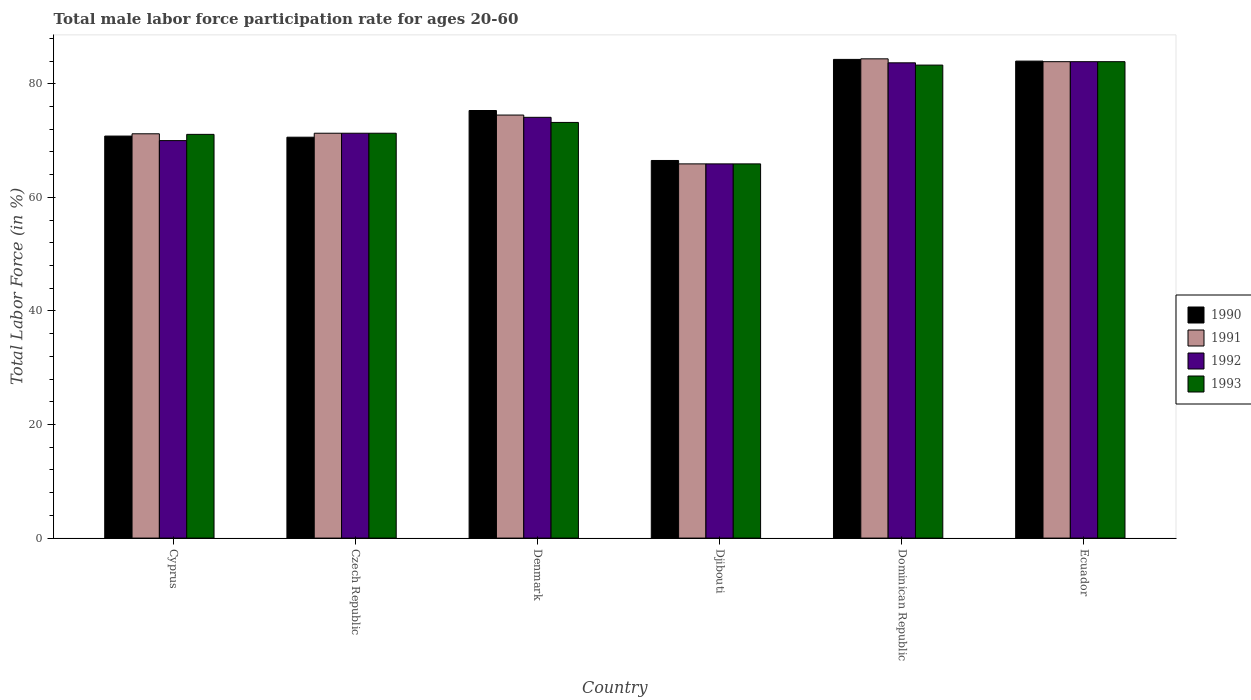Are the number of bars per tick equal to the number of legend labels?
Keep it short and to the point. Yes. What is the label of the 1st group of bars from the left?
Your response must be concise. Cyprus. What is the male labor force participation rate in 1990 in Djibouti?
Keep it short and to the point. 66.5. Across all countries, what is the maximum male labor force participation rate in 1992?
Provide a short and direct response. 83.9. Across all countries, what is the minimum male labor force participation rate in 1992?
Your answer should be very brief. 65.9. In which country was the male labor force participation rate in 1990 maximum?
Your answer should be very brief. Dominican Republic. In which country was the male labor force participation rate in 1991 minimum?
Provide a succinct answer. Djibouti. What is the total male labor force participation rate in 1992 in the graph?
Give a very brief answer. 448.9. What is the difference between the male labor force participation rate in 1993 in Djibouti and that in Ecuador?
Make the answer very short. -18. What is the difference between the male labor force participation rate in 1990 in Denmark and the male labor force participation rate in 1993 in Ecuador?
Your response must be concise. -8.6. What is the average male labor force participation rate in 1992 per country?
Your answer should be compact. 74.82. What is the difference between the male labor force participation rate of/in 1992 and male labor force participation rate of/in 1990 in Czech Republic?
Make the answer very short. 0.7. What is the ratio of the male labor force participation rate in 1993 in Czech Republic to that in Djibouti?
Ensure brevity in your answer.  1.08. Is the male labor force participation rate in 1991 in Dominican Republic less than that in Ecuador?
Provide a succinct answer. No. What is the difference between the highest and the second highest male labor force participation rate in 1990?
Provide a succinct answer. -9. What is the difference between the highest and the lowest male labor force participation rate in 1992?
Ensure brevity in your answer.  18. In how many countries, is the male labor force participation rate in 1990 greater than the average male labor force participation rate in 1990 taken over all countries?
Make the answer very short. 3. Is the sum of the male labor force participation rate in 1990 in Cyprus and Czech Republic greater than the maximum male labor force participation rate in 1993 across all countries?
Provide a short and direct response. Yes. What does the 2nd bar from the left in Cyprus represents?
Your answer should be very brief. 1991. What does the 3rd bar from the right in Denmark represents?
Your answer should be compact. 1991. Is it the case that in every country, the sum of the male labor force participation rate in 1990 and male labor force participation rate in 1991 is greater than the male labor force participation rate in 1993?
Make the answer very short. Yes. How many countries are there in the graph?
Provide a succinct answer. 6. Are the values on the major ticks of Y-axis written in scientific E-notation?
Provide a short and direct response. No. Does the graph contain any zero values?
Provide a succinct answer. No. Where does the legend appear in the graph?
Give a very brief answer. Center right. What is the title of the graph?
Your answer should be very brief. Total male labor force participation rate for ages 20-60. What is the label or title of the Y-axis?
Make the answer very short. Total Labor Force (in %). What is the Total Labor Force (in %) of 1990 in Cyprus?
Offer a terse response. 70.8. What is the Total Labor Force (in %) of 1991 in Cyprus?
Keep it short and to the point. 71.2. What is the Total Labor Force (in %) of 1992 in Cyprus?
Offer a terse response. 70. What is the Total Labor Force (in %) of 1993 in Cyprus?
Provide a succinct answer. 71.1. What is the Total Labor Force (in %) in 1990 in Czech Republic?
Keep it short and to the point. 70.6. What is the Total Labor Force (in %) of 1991 in Czech Republic?
Make the answer very short. 71.3. What is the Total Labor Force (in %) of 1992 in Czech Republic?
Offer a terse response. 71.3. What is the Total Labor Force (in %) in 1993 in Czech Republic?
Provide a short and direct response. 71.3. What is the Total Labor Force (in %) in 1990 in Denmark?
Offer a very short reply. 75.3. What is the Total Labor Force (in %) in 1991 in Denmark?
Offer a very short reply. 74.5. What is the Total Labor Force (in %) in 1992 in Denmark?
Give a very brief answer. 74.1. What is the Total Labor Force (in %) in 1993 in Denmark?
Your answer should be compact. 73.2. What is the Total Labor Force (in %) in 1990 in Djibouti?
Offer a very short reply. 66.5. What is the Total Labor Force (in %) in 1991 in Djibouti?
Your response must be concise. 65.9. What is the Total Labor Force (in %) of 1992 in Djibouti?
Your answer should be very brief. 65.9. What is the Total Labor Force (in %) of 1993 in Djibouti?
Keep it short and to the point. 65.9. What is the Total Labor Force (in %) of 1990 in Dominican Republic?
Provide a short and direct response. 84.3. What is the Total Labor Force (in %) in 1991 in Dominican Republic?
Offer a terse response. 84.4. What is the Total Labor Force (in %) in 1992 in Dominican Republic?
Give a very brief answer. 83.7. What is the Total Labor Force (in %) of 1993 in Dominican Republic?
Offer a very short reply. 83.3. What is the Total Labor Force (in %) of 1991 in Ecuador?
Provide a succinct answer. 83.9. What is the Total Labor Force (in %) of 1992 in Ecuador?
Your response must be concise. 83.9. What is the Total Labor Force (in %) in 1993 in Ecuador?
Your answer should be compact. 83.9. Across all countries, what is the maximum Total Labor Force (in %) of 1990?
Your answer should be very brief. 84.3. Across all countries, what is the maximum Total Labor Force (in %) of 1991?
Your response must be concise. 84.4. Across all countries, what is the maximum Total Labor Force (in %) in 1992?
Keep it short and to the point. 83.9. Across all countries, what is the maximum Total Labor Force (in %) in 1993?
Your response must be concise. 83.9. Across all countries, what is the minimum Total Labor Force (in %) in 1990?
Your response must be concise. 66.5. Across all countries, what is the minimum Total Labor Force (in %) in 1991?
Provide a short and direct response. 65.9. Across all countries, what is the minimum Total Labor Force (in %) in 1992?
Give a very brief answer. 65.9. Across all countries, what is the minimum Total Labor Force (in %) of 1993?
Offer a terse response. 65.9. What is the total Total Labor Force (in %) in 1990 in the graph?
Provide a succinct answer. 451.5. What is the total Total Labor Force (in %) of 1991 in the graph?
Your answer should be compact. 451.2. What is the total Total Labor Force (in %) of 1992 in the graph?
Keep it short and to the point. 448.9. What is the total Total Labor Force (in %) of 1993 in the graph?
Your answer should be compact. 448.7. What is the difference between the Total Labor Force (in %) in 1991 in Cyprus and that in Czech Republic?
Offer a terse response. -0.1. What is the difference between the Total Labor Force (in %) of 1992 in Cyprus and that in Czech Republic?
Keep it short and to the point. -1.3. What is the difference between the Total Labor Force (in %) in 1990 in Cyprus and that in Denmark?
Provide a short and direct response. -4.5. What is the difference between the Total Labor Force (in %) in 1993 in Cyprus and that in Denmark?
Provide a short and direct response. -2.1. What is the difference between the Total Labor Force (in %) in 1990 in Cyprus and that in Djibouti?
Offer a very short reply. 4.3. What is the difference between the Total Labor Force (in %) of 1992 in Cyprus and that in Djibouti?
Offer a very short reply. 4.1. What is the difference between the Total Labor Force (in %) of 1990 in Cyprus and that in Dominican Republic?
Keep it short and to the point. -13.5. What is the difference between the Total Labor Force (in %) in 1991 in Cyprus and that in Dominican Republic?
Make the answer very short. -13.2. What is the difference between the Total Labor Force (in %) in 1992 in Cyprus and that in Dominican Republic?
Your answer should be very brief. -13.7. What is the difference between the Total Labor Force (in %) of 1991 in Cyprus and that in Ecuador?
Keep it short and to the point. -12.7. What is the difference between the Total Labor Force (in %) in 1992 in Czech Republic and that in Denmark?
Your response must be concise. -2.8. What is the difference between the Total Labor Force (in %) in 1990 in Czech Republic and that in Djibouti?
Keep it short and to the point. 4.1. What is the difference between the Total Labor Force (in %) of 1991 in Czech Republic and that in Djibouti?
Offer a very short reply. 5.4. What is the difference between the Total Labor Force (in %) of 1993 in Czech Republic and that in Djibouti?
Your answer should be very brief. 5.4. What is the difference between the Total Labor Force (in %) in 1990 in Czech Republic and that in Dominican Republic?
Your response must be concise. -13.7. What is the difference between the Total Labor Force (in %) in 1991 in Czech Republic and that in Dominican Republic?
Your response must be concise. -13.1. What is the difference between the Total Labor Force (in %) in 1993 in Czech Republic and that in Dominican Republic?
Offer a terse response. -12. What is the difference between the Total Labor Force (in %) of 1990 in Czech Republic and that in Ecuador?
Offer a terse response. -13.4. What is the difference between the Total Labor Force (in %) in 1993 in Czech Republic and that in Ecuador?
Provide a succinct answer. -12.6. What is the difference between the Total Labor Force (in %) in 1990 in Denmark and that in Djibouti?
Your response must be concise. 8.8. What is the difference between the Total Labor Force (in %) of 1991 in Denmark and that in Djibouti?
Give a very brief answer. 8.6. What is the difference between the Total Labor Force (in %) in 1992 in Denmark and that in Djibouti?
Provide a succinct answer. 8.2. What is the difference between the Total Labor Force (in %) of 1991 in Denmark and that in Dominican Republic?
Offer a terse response. -9.9. What is the difference between the Total Labor Force (in %) in 1992 in Denmark and that in Dominican Republic?
Ensure brevity in your answer.  -9.6. What is the difference between the Total Labor Force (in %) of 1990 in Djibouti and that in Dominican Republic?
Give a very brief answer. -17.8. What is the difference between the Total Labor Force (in %) in 1991 in Djibouti and that in Dominican Republic?
Keep it short and to the point. -18.5. What is the difference between the Total Labor Force (in %) in 1992 in Djibouti and that in Dominican Republic?
Offer a terse response. -17.8. What is the difference between the Total Labor Force (in %) in 1993 in Djibouti and that in Dominican Republic?
Your response must be concise. -17.4. What is the difference between the Total Labor Force (in %) of 1990 in Djibouti and that in Ecuador?
Your response must be concise. -17.5. What is the difference between the Total Labor Force (in %) in 1993 in Djibouti and that in Ecuador?
Your answer should be very brief. -18. What is the difference between the Total Labor Force (in %) of 1990 in Dominican Republic and that in Ecuador?
Your response must be concise. 0.3. What is the difference between the Total Labor Force (in %) in 1992 in Dominican Republic and that in Ecuador?
Your response must be concise. -0.2. What is the difference between the Total Labor Force (in %) in 1990 in Cyprus and the Total Labor Force (in %) in 1991 in Czech Republic?
Give a very brief answer. -0.5. What is the difference between the Total Labor Force (in %) of 1992 in Cyprus and the Total Labor Force (in %) of 1993 in Czech Republic?
Ensure brevity in your answer.  -1.3. What is the difference between the Total Labor Force (in %) in 1990 in Cyprus and the Total Labor Force (in %) in 1992 in Denmark?
Offer a very short reply. -3.3. What is the difference between the Total Labor Force (in %) of 1991 in Cyprus and the Total Labor Force (in %) of 1992 in Denmark?
Give a very brief answer. -2.9. What is the difference between the Total Labor Force (in %) of 1991 in Cyprus and the Total Labor Force (in %) of 1993 in Denmark?
Your answer should be compact. -2. What is the difference between the Total Labor Force (in %) of 1990 in Cyprus and the Total Labor Force (in %) of 1991 in Djibouti?
Your response must be concise. 4.9. What is the difference between the Total Labor Force (in %) of 1990 in Cyprus and the Total Labor Force (in %) of 1992 in Djibouti?
Give a very brief answer. 4.9. What is the difference between the Total Labor Force (in %) of 1991 in Cyprus and the Total Labor Force (in %) of 1993 in Djibouti?
Your response must be concise. 5.3. What is the difference between the Total Labor Force (in %) in 1990 in Cyprus and the Total Labor Force (in %) in 1991 in Dominican Republic?
Your answer should be very brief. -13.6. What is the difference between the Total Labor Force (in %) in 1990 in Cyprus and the Total Labor Force (in %) in 1992 in Dominican Republic?
Provide a succinct answer. -12.9. What is the difference between the Total Labor Force (in %) of 1991 in Cyprus and the Total Labor Force (in %) of 1993 in Dominican Republic?
Provide a succinct answer. -12.1. What is the difference between the Total Labor Force (in %) in 1992 in Cyprus and the Total Labor Force (in %) in 1993 in Dominican Republic?
Provide a succinct answer. -13.3. What is the difference between the Total Labor Force (in %) of 1990 in Cyprus and the Total Labor Force (in %) of 1991 in Ecuador?
Keep it short and to the point. -13.1. What is the difference between the Total Labor Force (in %) in 1990 in Cyprus and the Total Labor Force (in %) in 1993 in Ecuador?
Your response must be concise. -13.1. What is the difference between the Total Labor Force (in %) in 1991 in Cyprus and the Total Labor Force (in %) in 1992 in Ecuador?
Provide a succinct answer. -12.7. What is the difference between the Total Labor Force (in %) of 1992 in Cyprus and the Total Labor Force (in %) of 1993 in Ecuador?
Make the answer very short. -13.9. What is the difference between the Total Labor Force (in %) of 1990 in Czech Republic and the Total Labor Force (in %) of 1991 in Denmark?
Keep it short and to the point. -3.9. What is the difference between the Total Labor Force (in %) of 1990 in Czech Republic and the Total Labor Force (in %) of 1992 in Denmark?
Keep it short and to the point. -3.5. What is the difference between the Total Labor Force (in %) of 1992 in Czech Republic and the Total Labor Force (in %) of 1993 in Denmark?
Provide a succinct answer. -1.9. What is the difference between the Total Labor Force (in %) of 1990 in Czech Republic and the Total Labor Force (in %) of 1991 in Djibouti?
Offer a very short reply. 4.7. What is the difference between the Total Labor Force (in %) of 1990 in Czech Republic and the Total Labor Force (in %) of 1993 in Djibouti?
Offer a very short reply. 4.7. What is the difference between the Total Labor Force (in %) of 1991 in Czech Republic and the Total Labor Force (in %) of 1992 in Djibouti?
Ensure brevity in your answer.  5.4. What is the difference between the Total Labor Force (in %) of 1991 in Czech Republic and the Total Labor Force (in %) of 1993 in Djibouti?
Provide a succinct answer. 5.4. What is the difference between the Total Labor Force (in %) in 1992 in Czech Republic and the Total Labor Force (in %) in 1993 in Djibouti?
Make the answer very short. 5.4. What is the difference between the Total Labor Force (in %) of 1990 in Czech Republic and the Total Labor Force (in %) of 1991 in Dominican Republic?
Make the answer very short. -13.8. What is the difference between the Total Labor Force (in %) of 1990 in Czech Republic and the Total Labor Force (in %) of 1992 in Dominican Republic?
Your answer should be compact. -13.1. What is the difference between the Total Labor Force (in %) of 1991 in Czech Republic and the Total Labor Force (in %) of 1992 in Dominican Republic?
Your answer should be compact. -12.4. What is the difference between the Total Labor Force (in %) in 1991 in Czech Republic and the Total Labor Force (in %) in 1993 in Dominican Republic?
Give a very brief answer. -12. What is the difference between the Total Labor Force (in %) of 1990 in Czech Republic and the Total Labor Force (in %) of 1991 in Ecuador?
Offer a very short reply. -13.3. What is the difference between the Total Labor Force (in %) of 1990 in Czech Republic and the Total Labor Force (in %) of 1992 in Ecuador?
Your answer should be very brief. -13.3. What is the difference between the Total Labor Force (in %) of 1990 in Czech Republic and the Total Labor Force (in %) of 1993 in Ecuador?
Give a very brief answer. -13.3. What is the difference between the Total Labor Force (in %) in 1990 in Denmark and the Total Labor Force (in %) in 1991 in Djibouti?
Your response must be concise. 9.4. What is the difference between the Total Labor Force (in %) in 1990 in Denmark and the Total Labor Force (in %) in 1993 in Djibouti?
Ensure brevity in your answer.  9.4. What is the difference between the Total Labor Force (in %) of 1991 in Denmark and the Total Labor Force (in %) of 1992 in Djibouti?
Provide a short and direct response. 8.6. What is the difference between the Total Labor Force (in %) in 1992 in Denmark and the Total Labor Force (in %) in 1993 in Djibouti?
Keep it short and to the point. 8.2. What is the difference between the Total Labor Force (in %) of 1990 in Denmark and the Total Labor Force (in %) of 1991 in Dominican Republic?
Offer a very short reply. -9.1. What is the difference between the Total Labor Force (in %) in 1990 in Denmark and the Total Labor Force (in %) in 1992 in Dominican Republic?
Provide a succinct answer. -8.4. What is the difference between the Total Labor Force (in %) in 1990 in Denmark and the Total Labor Force (in %) in 1993 in Dominican Republic?
Offer a terse response. -8. What is the difference between the Total Labor Force (in %) of 1991 in Denmark and the Total Labor Force (in %) of 1993 in Dominican Republic?
Your answer should be very brief. -8.8. What is the difference between the Total Labor Force (in %) in 1992 in Denmark and the Total Labor Force (in %) in 1993 in Dominican Republic?
Provide a succinct answer. -9.2. What is the difference between the Total Labor Force (in %) in 1990 in Denmark and the Total Labor Force (in %) in 1991 in Ecuador?
Your answer should be very brief. -8.6. What is the difference between the Total Labor Force (in %) in 1990 in Denmark and the Total Labor Force (in %) in 1992 in Ecuador?
Give a very brief answer. -8.6. What is the difference between the Total Labor Force (in %) in 1991 in Denmark and the Total Labor Force (in %) in 1993 in Ecuador?
Make the answer very short. -9.4. What is the difference between the Total Labor Force (in %) in 1990 in Djibouti and the Total Labor Force (in %) in 1991 in Dominican Republic?
Provide a succinct answer. -17.9. What is the difference between the Total Labor Force (in %) of 1990 in Djibouti and the Total Labor Force (in %) of 1992 in Dominican Republic?
Your response must be concise. -17.2. What is the difference between the Total Labor Force (in %) in 1990 in Djibouti and the Total Labor Force (in %) in 1993 in Dominican Republic?
Provide a short and direct response. -16.8. What is the difference between the Total Labor Force (in %) of 1991 in Djibouti and the Total Labor Force (in %) of 1992 in Dominican Republic?
Give a very brief answer. -17.8. What is the difference between the Total Labor Force (in %) of 1991 in Djibouti and the Total Labor Force (in %) of 1993 in Dominican Republic?
Offer a terse response. -17.4. What is the difference between the Total Labor Force (in %) of 1992 in Djibouti and the Total Labor Force (in %) of 1993 in Dominican Republic?
Ensure brevity in your answer.  -17.4. What is the difference between the Total Labor Force (in %) in 1990 in Djibouti and the Total Labor Force (in %) in 1991 in Ecuador?
Provide a short and direct response. -17.4. What is the difference between the Total Labor Force (in %) in 1990 in Djibouti and the Total Labor Force (in %) in 1992 in Ecuador?
Keep it short and to the point. -17.4. What is the difference between the Total Labor Force (in %) of 1990 in Djibouti and the Total Labor Force (in %) of 1993 in Ecuador?
Make the answer very short. -17.4. What is the difference between the Total Labor Force (in %) in 1990 in Dominican Republic and the Total Labor Force (in %) in 1993 in Ecuador?
Make the answer very short. 0.4. What is the difference between the Total Labor Force (in %) in 1991 in Dominican Republic and the Total Labor Force (in %) in 1992 in Ecuador?
Your response must be concise. 0.5. What is the difference between the Total Labor Force (in %) of 1991 in Dominican Republic and the Total Labor Force (in %) of 1993 in Ecuador?
Make the answer very short. 0.5. What is the average Total Labor Force (in %) of 1990 per country?
Your response must be concise. 75.25. What is the average Total Labor Force (in %) in 1991 per country?
Keep it short and to the point. 75.2. What is the average Total Labor Force (in %) of 1992 per country?
Give a very brief answer. 74.82. What is the average Total Labor Force (in %) in 1993 per country?
Give a very brief answer. 74.78. What is the difference between the Total Labor Force (in %) in 1990 and Total Labor Force (in %) in 1991 in Cyprus?
Your answer should be compact. -0.4. What is the difference between the Total Labor Force (in %) of 1990 and Total Labor Force (in %) of 1993 in Cyprus?
Provide a succinct answer. -0.3. What is the difference between the Total Labor Force (in %) of 1991 and Total Labor Force (in %) of 1993 in Cyprus?
Provide a succinct answer. 0.1. What is the difference between the Total Labor Force (in %) in 1992 and Total Labor Force (in %) in 1993 in Cyprus?
Provide a succinct answer. -1.1. What is the difference between the Total Labor Force (in %) of 1990 and Total Labor Force (in %) of 1991 in Czech Republic?
Your answer should be very brief. -0.7. What is the difference between the Total Labor Force (in %) of 1990 and Total Labor Force (in %) of 1992 in Czech Republic?
Your answer should be compact. -0.7. What is the difference between the Total Labor Force (in %) of 1991 and Total Labor Force (in %) of 1993 in Czech Republic?
Provide a short and direct response. 0. What is the difference between the Total Labor Force (in %) of 1992 and Total Labor Force (in %) of 1993 in Czech Republic?
Your answer should be compact. 0. What is the difference between the Total Labor Force (in %) of 1990 and Total Labor Force (in %) of 1991 in Denmark?
Make the answer very short. 0.8. What is the difference between the Total Labor Force (in %) in 1990 and Total Labor Force (in %) in 1992 in Djibouti?
Provide a succinct answer. 0.6. What is the difference between the Total Labor Force (in %) in 1992 and Total Labor Force (in %) in 1993 in Djibouti?
Provide a short and direct response. 0. What is the difference between the Total Labor Force (in %) of 1990 and Total Labor Force (in %) of 1991 in Dominican Republic?
Provide a succinct answer. -0.1. What is the difference between the Total Labor Force (in %) of 1990 and Total Labor Force (in %) of 1992 in Dominican Republic?
Make the answer very short. 0.6. What is the difference between the Total Labor Force (in %) of 1990 and Total Labor Force (in %) of 1993 in Dominican Republic?
Offer a terse response. 1. What is the difference between the Total Labor Force (in %) of 1991 and Total Labor Force (in %) of 1992 in Dominican Republic?
Offer a very short reply. 0.7. What is the difference between the Total Labor Force (in %) in 1990 and Total Labor Force (in %) in 1991 in Ecuador?
Keep it short and to the point. 0.1. What is the difference between the Total Labor Force (in %) of 1990 and Total Labor Force (in %) of 1992 in Ecuador?
Make the answer very short. 0.1. What is the difference between the Total Labor Force (in %) in 1991 and Total Labor Force (in %) in 1993 in Ecuador?
Provide a short and direct response. 0. What is the difference between the Total Labor Force (in %) of 1992 and Total Labor Force (in %) of 1993 in Ecuador?
Your response must be concise. 0. What is the ratio of the Total Labor Force (in %) of 1990 in Cyprus to that in Czech Republic?
Give a very brief answer. 1. What is the ratio of the Total Labor Force (in %) in 1992 in Cyprus to that in Czech Republic?
Provide a short and direct response. 0.98. What is the ratio of the Total Labor Force (in %) of 1993 in Cyprus to that in Czech Republic?
Make the answer very short. 1. What is the ratio of the Total Labor Force (in %) of 1990 in Cyprus to that in Denmark?
Provide a succinct answer. 0.94. What is the ratio of the Total Labor Force (in %) in 1991 in Cyprus to that in Denmark?
Offer a very short reply. 0.96. What is the ratio of the Total Labor Force (in %) in 1992 in Cyprus to that in Denmark?
Provide a succinct answer. 0.94. What is the ratio of the Total Labor Force (in %) in 1993 in Cyprus to that in Denmark?
Provide a short and direct response. 0.97. What is the ratio of the Total Labor Force (in %) of 1990 in Cyprus to that in Djibouti?
Your answer should be compact. 1.06. What is the ratio of the Total Labor Force (in %) in 1991 in Cyprus to that in Djibouti?
Your response must be concise. 1.08. What is the ratio of the Total Labor Force (in %) of 1992 in Cyprus to that in Djibouti?
Keep it short and to the point. 1.06. What is the ratio of the Total Labor Force (in %) in 1993 in Cyprus to that in Djibouti?
Your response must be concise. 1.08. What is the ratio of the Total Labor Force (in %) of 1990 in Cyprus to that in Dominican Republic?
Keep it short and to the point. 0.84. What is the ratio of the Total Labor Force (in %) of 1991 in Cyprus to that in Dominican Republic?
Give a very brief answer. 0.84. What is the ratio of the Total Labor Force (in %) of 1992 in Cyprus to that in Dominican Republic?
Ensure brevity in your answer.  0.84. What is the ratio of the Total Labor Force (in %) of 1993 in Cyprus to that in Dominican Republic?
Keep it short and to the point. 0.85. What is the ratio of the Total Labor Force (in %) of 1990 in Cyprus to that in Ecuador?
Provide a short and direct response. 0.84. What is the ratio of the Total Labor Force (in %) in 1991 in Cyprus to that in Ecuador?
Ensure brevity in your answer.  0.85. What is the ratio of the Total Labor Force (in %) of 1992 in Cyprus to that in Ecuador?
Provide a short and direct response. 0.83. What is the ratio of the Total Labor Force (in %) of 1993 in Cyprus to that in Ecuador?
Ensure brevity in your answer.  0.85. What is the ratio of the Total Labor Force (in %) of 1990 in Czech Republic to that in Denmark?
Your response must be concise. 0.94. What is the ratio of the Total Labor Force (in %) in 1991 in Czech Republic to that in Denmark?
Your answer should be very brief. 0.96. What is the ratio of the Total Labor Force (in %) in 1992 in Czech Republic to that in Denmark?
Offer a terse response. 0.96. What is the ratio of the Total Labor Force (in %) in 1990 in Czech Republic to that in Djibouti?
Keep it short and to the point. 1.06. What is the ratio of the Total Labor Force (in %) of 1991 in Czech Republic to that in Djibouti?
Your response must be concise. 1.08. What is the ratio of the Total Labor Force (in %) in 1992 in Czech Republic to that in Djibouti?
Provide a succinct answer. 1.08. What is the ratio of the Total Labor Force (in %) of 1993 in Czech Republic to that in Djibouti?
Provide a short and direct response. 1.08. What is the ratio of the Total Labor Force (in %) in 1990 in Czech Republic to that in Dominican Republic?
Ensure brevity in your answer.  0.84. What is the ratio of the Total Labor Force (in %) in 1991 in Czech Republic to that in Dominican Republic?
Your response must be concise. 0.84. What is the ratio of the Total Labor Force (in %) in 1992 in Czech Republic to that in Dominican Republic?
Your answer should be compact. 0.85. What is the ratio of the Total Labor Force (in %) in 1993 in Czech Republic to that in Dominican Republic?
Offer a very short reply. 0.86. What is the ratio of the Total Labor Force (in %) in 1990 in Czech Republic to that in Ecuador?
Provide a short and direct response. 0.84. What is the ratio of the Total Labor Force (in %) of 1991 in Czech Republic to that in Ecuador?
Your response must be concise. 0.85. What is the ratio of the Total Labor Force (in %) in 1992 in Czech Republic to that in Ecuador?
Offer a terse response. 0.85. What is the ratio of the Total Labor Force (in %) in 1993 in Czech Republic to that in Ecuador?
Offer a very short reply. 0.85. What is the ratio of the Total Labor Force (in %) in 1990 in Denmark to that in Djibouti?
Your answer should be compact. 1.13. What is the ratio of the Total Labor Force (in %) in 1991 in Denmark to that in Djibouti?
Ensure brevity in your answer.  1.13. What is the ratio of the Total Labor Force (in %) in 1992 in Denmark to that in Djibouti?
Offer a terse response. 1.12. What is the ratio of the Total Labor Force (in %) of 1993 in Denmark to that in Djibouti?
Give a very brief answer. 1.11. What is the ratio of the Total Labor Force (in %) in 1990 in Denmark to that in Dominican Republic?
Ensure brevity in your answer.  0.89. What is the ratio of the Total Labor Force (in %) of 1991 in Denmark to that in Dominican Republic?
Ensure brevity in your answer.  0.88. What is the ratio of the Total Labor Force (in %) of 1992 in Denmark to that in Dominican Republic?
Give a very brief answer. 0.89. What is the ratio of the Total Labor Force (in %) in 1993 in Denmark to that in Dominican Republic?
Ensure brevity in your answer.  0.88. What is the ratio of the Total Labor Force (in %) of 1990 in Denmark to that in Ecuador?
Your answer should be compact. 0.9. What is the ratio of the Total Labor Force (in %) of 1991 in Denmark to that in Ecuador?
Your answer should be compact. 0.89. What is the ratio of the Total Labor Force (in %) of 1992 in Denmark to that in Ecuador?
Provide a succinct answer. 0.88. What is the ratio of the Total Labor Force (in %) of 1993 in Denmark to that in Ecuador?
Ensure brevity in your answer.  0.87. What is the ratio of the Total Labor Force (in %) in 1990 in Djibouti to that in Dominican Republic?
Provide a short and direct response. 0.79. What is the ratio of the Total Labor Force (in %) in 1991 in Djibouti to that in Dominican Republic?
Your answer should be compact. 0.78. What is the ratio of the Total Labor Force (in %) of 1992 in Djibouti to that in Dominican Republic?
Your answer should be compact. 0.79. What is the ratio of the Total Labor Force (in %) in 1993 in Djibouti to that in Dominican Republic?
Provide a short and direct response. 0.79. What is the ratio of the Total Labor Force (in %) in 1990 in Djibouti to that in Ecuador?
Offer a terse response. 0.79. What is the ratio of the Total Labor Force (in %) in 1991 in Djibouti to that in Ecuador?
Your answer should be compact. 0.79. What is the ratio of the Total Labor Force (in %) of 1992 in Djibouti to that in Ecuador?
Offer a terse response. 0.79. What is the ratio of the Total Labor Force (in %) of 1993 in Djibouti to that in Ecuador?
Your answer should be compact. 0.79. What is the difference between the highest and the second highest Total Labor Force (in %) in 1991?
Make the answer very short. 0.5. What is the difference between the highest and the lowest Total Labor Force (in %) in 1992?
Keep it short and to the point. 18. 